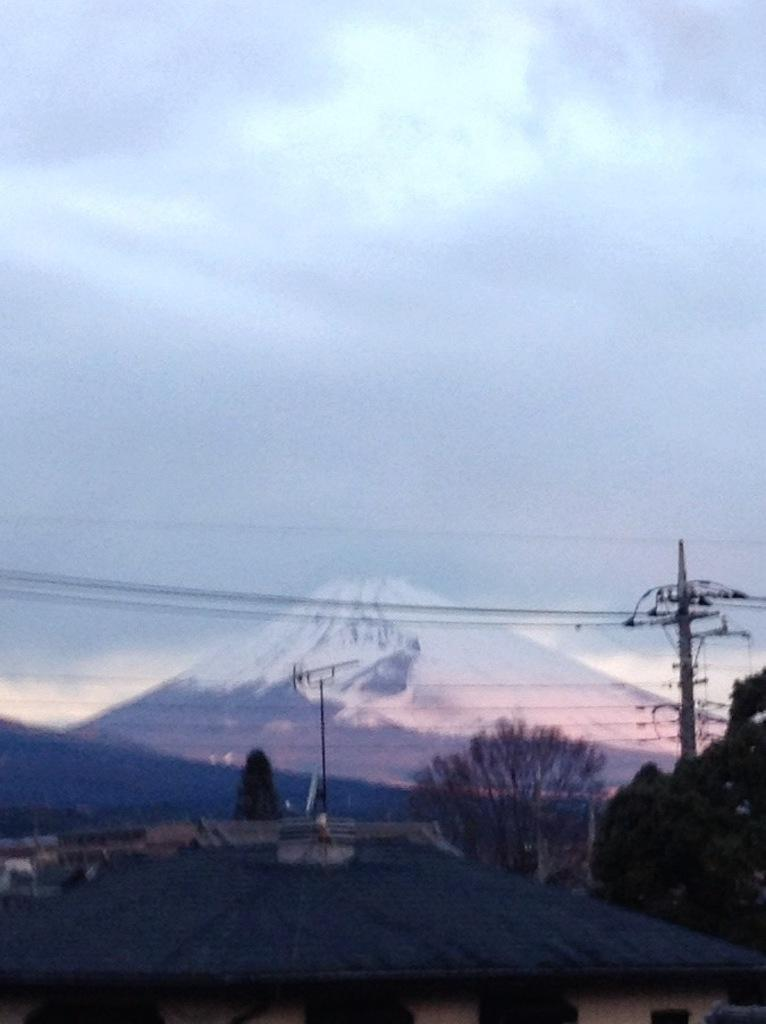What structures are present in the image? There are poles and wires in the image. What type of natural elements can be seen in the image? There are trees in the image. What is visible in the background of the image? There is a mountain and a cloudy sky in the background of the image. What grade does the mountain receive for its appearance in the image? The image does not include a grading system for the mountain's appearance, so it cannot be determined. 